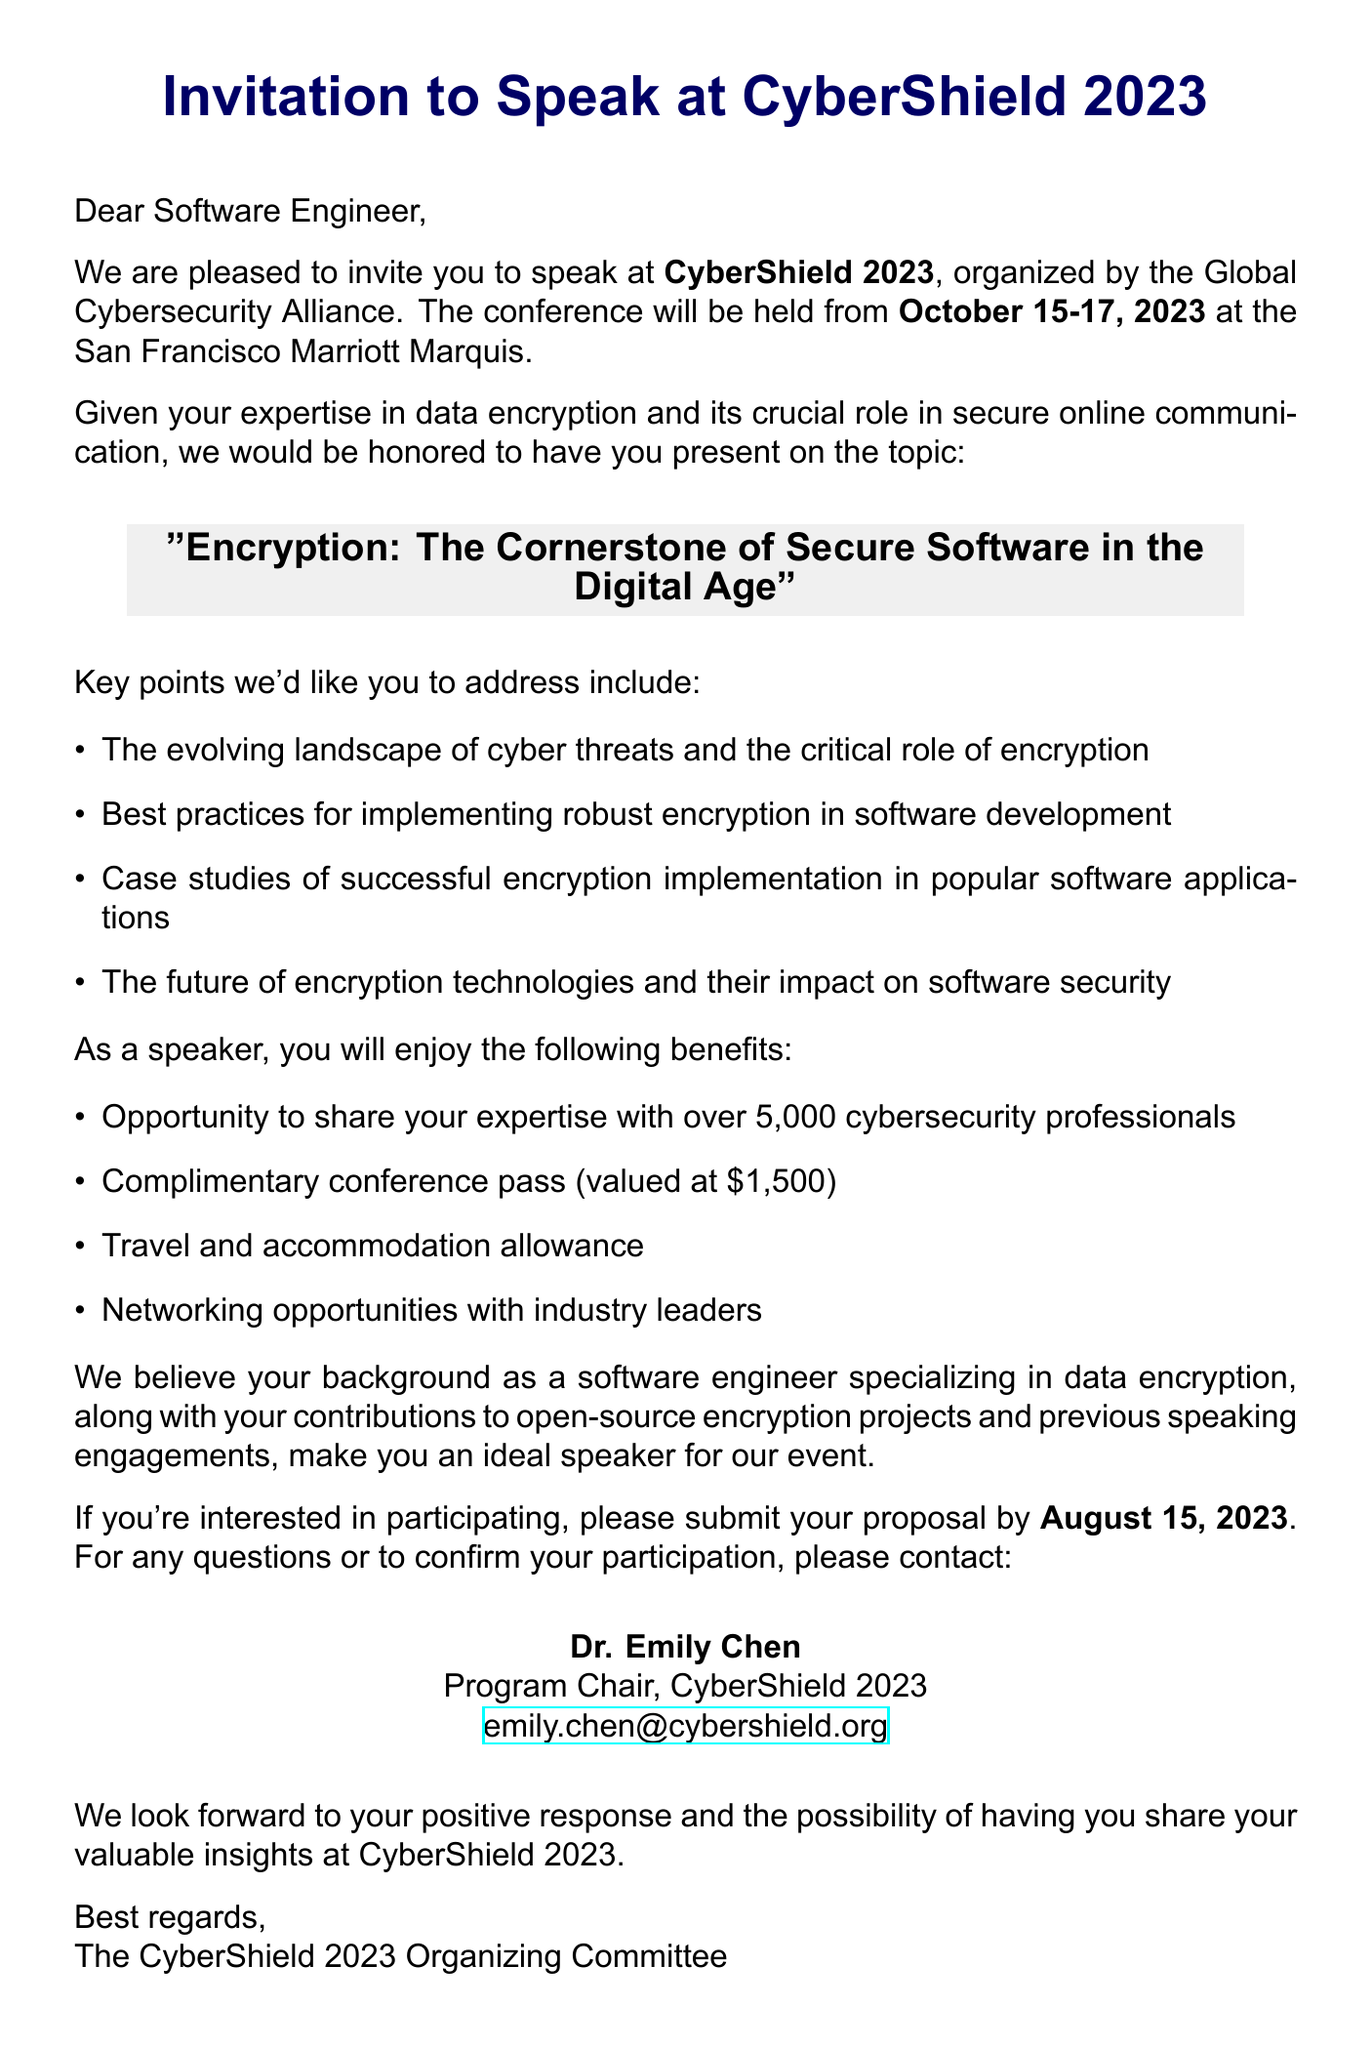What is the name of the conference? The name of the conference is mentioned in the document as CyberShield 2023.
Answer: CyberShield 2023 What are the dates for CyberShield 2023? The dates for the conference are specified in the document as October 15-17, 2023.
Answer: October 15-17, 2023 Who is the organizer of the conference? The organizer of the event is clearly stated in the document as the Global Cybersecurity Alliance.
Answer: Global Cybersecurity Alliance What is the proposed talk title? The proposed talk title can be found in the document, which is "Encryption: The Cornerstone of Secure Software in the Digital Age".
Answer: Encryption: The Cornerstone of Secure Software in the Digital Age What is one benefit of speaking at CyberShield 2023? The document lists multiple benefits, one of which is a complimentary conference pass worth $1,500.
Answer: Complimentary conference pass (valued at $1,500) What is the submission deadline for the proposal? The document specifies the submission deadline, indicating proposals are due by August 15, 2023.
Answer: August 15, 2023 Who should be contacted for further questions? The contact person for questions is mentioned in the document as Dr. Emily Chen.
Answer: Dr. Emily Chen What will the speaker have the opportunity to share? The document states the speaker will have the opportunity to share expertise with over 5,000 cybersecurity professionals.
Answer: Expertise with over 5,000 cybersecurity professionals What type of experiences are highlighted as relevant for the speaker? The document points out that the speaker's background as a software engineer specializing in data encryption is relevant.
Answer: Background as a software engineer specializing in data encryption 